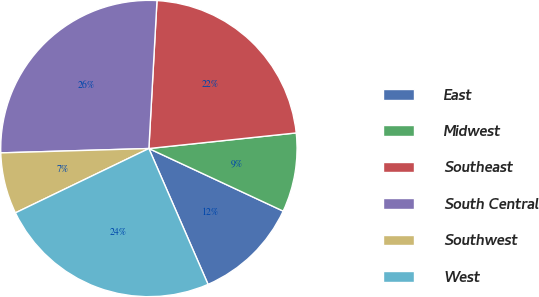Convert chart to OTSL. <chart><loc_0><loc_0><loc_500><loc_500><pie_chart><fcel>East<fcel>Midwest<fcel>Southeast<fcel>South Central<fcel>Southwest<fcel>West<nl><fcel>11.52%<fcel>8.62%<fcel>22.45%<fcel>26.34%<fcel>6.68%<fcel>24.39%<nl></chart> 